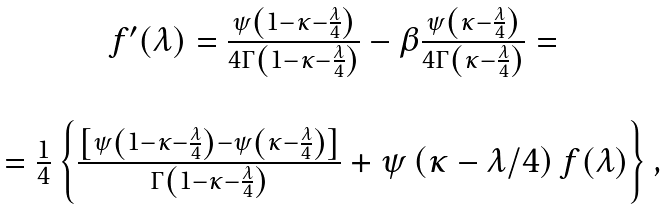Convert formula to latex. <formula><loc_0><loc_0><loc_500><loc_500>\begin{array} { c } f ^ { \prime } ( \lambda ) = \frac { \psi \left ( 1 - \kappa - \frac { \lambda } { 4 } \right ) } { 4 \Gamma \left ( 1 - \kappa - \frac { \lambda } { 4 } \right ) } - \beta \frac { \psi \left ( \kappa - \frac { \lambda } { 4 } \right ) } { 4 \Gamma \left ( \kappa - \frac { \lambda } { 4 } \right ) } = \\ \\ = \frac { 1 } { 4 } \left \{ \frac { \left [ \psi \left ( 1 - \kappa - \frac { \lambda } { 4 } \right ) - \psi \left ( \kappa - \frac { \lambda } { 4 } \right ) \right ] } { \Gamma \left ( 1 - \kappa - \frac { \lambda } { 4 } \right ) } + \psi \left ( \kappa - \lambda / 4 \right ) f ( \lambda ) \right \} , \end{array}</formula> 